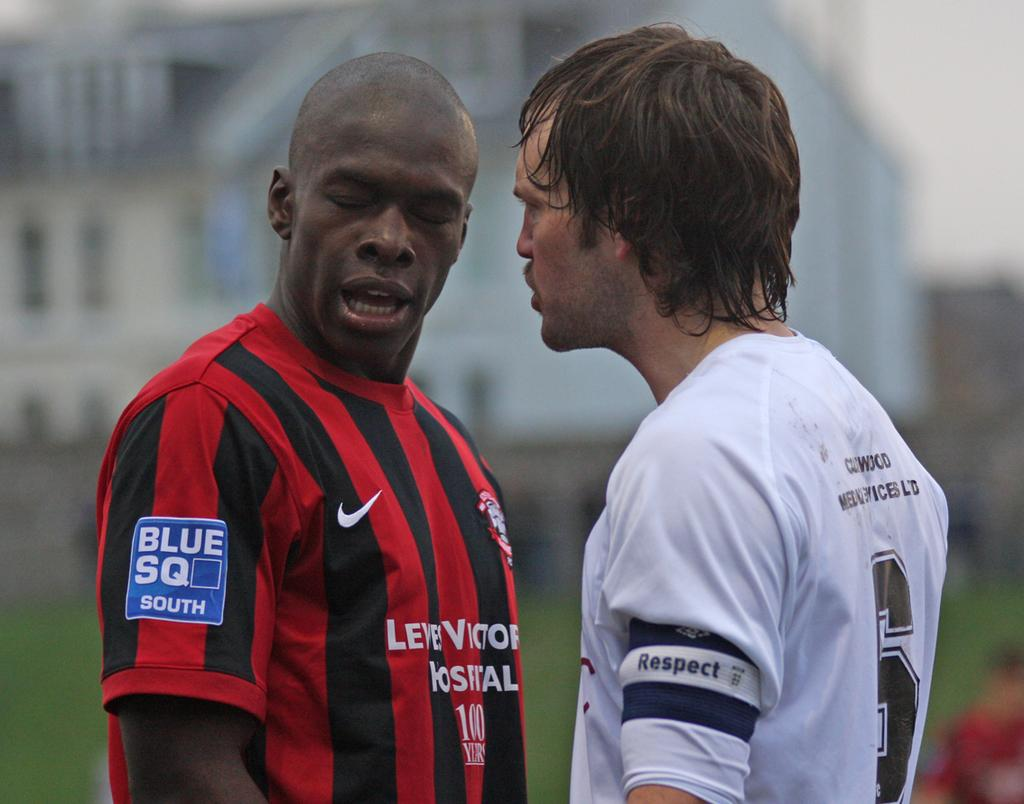<image>
Give a short and clear explanation of the subsequent image. Two soccer players facing each other with one shirt saying Blue SQ South. 